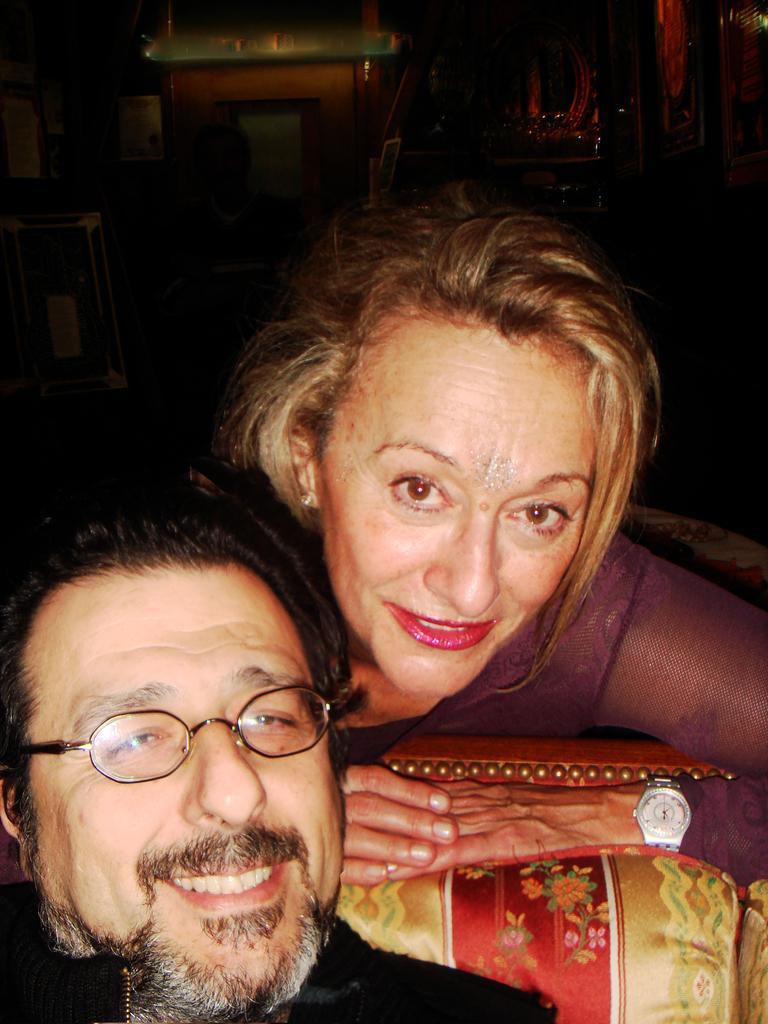In one or two sentences, can you explain what this image depicts? Here in this picture we can see a man and a woman lying over a place and both of them are smiling and the man is wearing spectacles. 